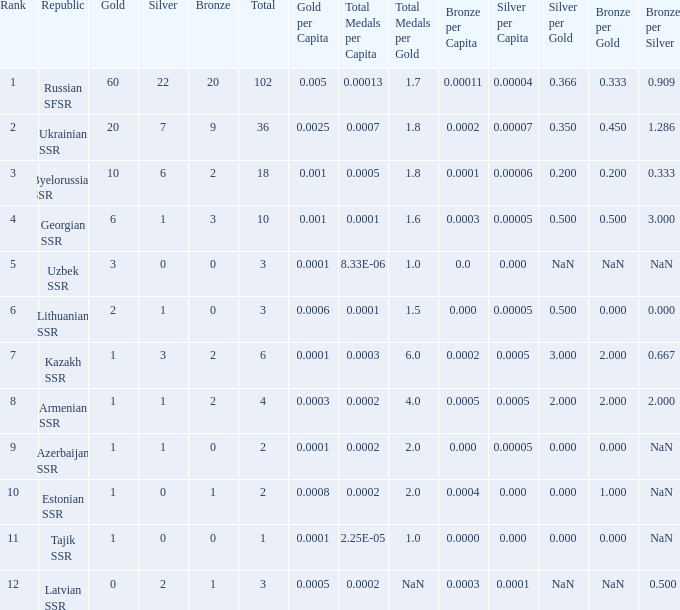What is the total number of bronzes associated with 1 silver, ranks under 6 and under 6 golds? None. 